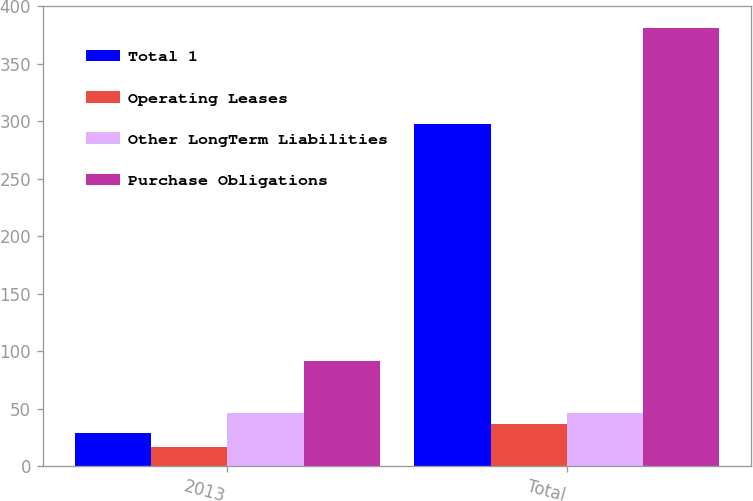<chart> <loc_0><loc_0><loc_500><loc_500><stacked_bar_chart><ecel><fcel>2013<fcel>Total<nl><fcel>Total 1<fcel>28.7<fcel>297.8<nl><fcel>Operating Leases<fcel>16.6<fcel>36.8<nl><fcel>Other LongTerm Liabilities<fcel>46.4<fcel>46.4<nl><fcel>Purchase Obligations<fcel>91.7<fcel>381<nl></chart> 